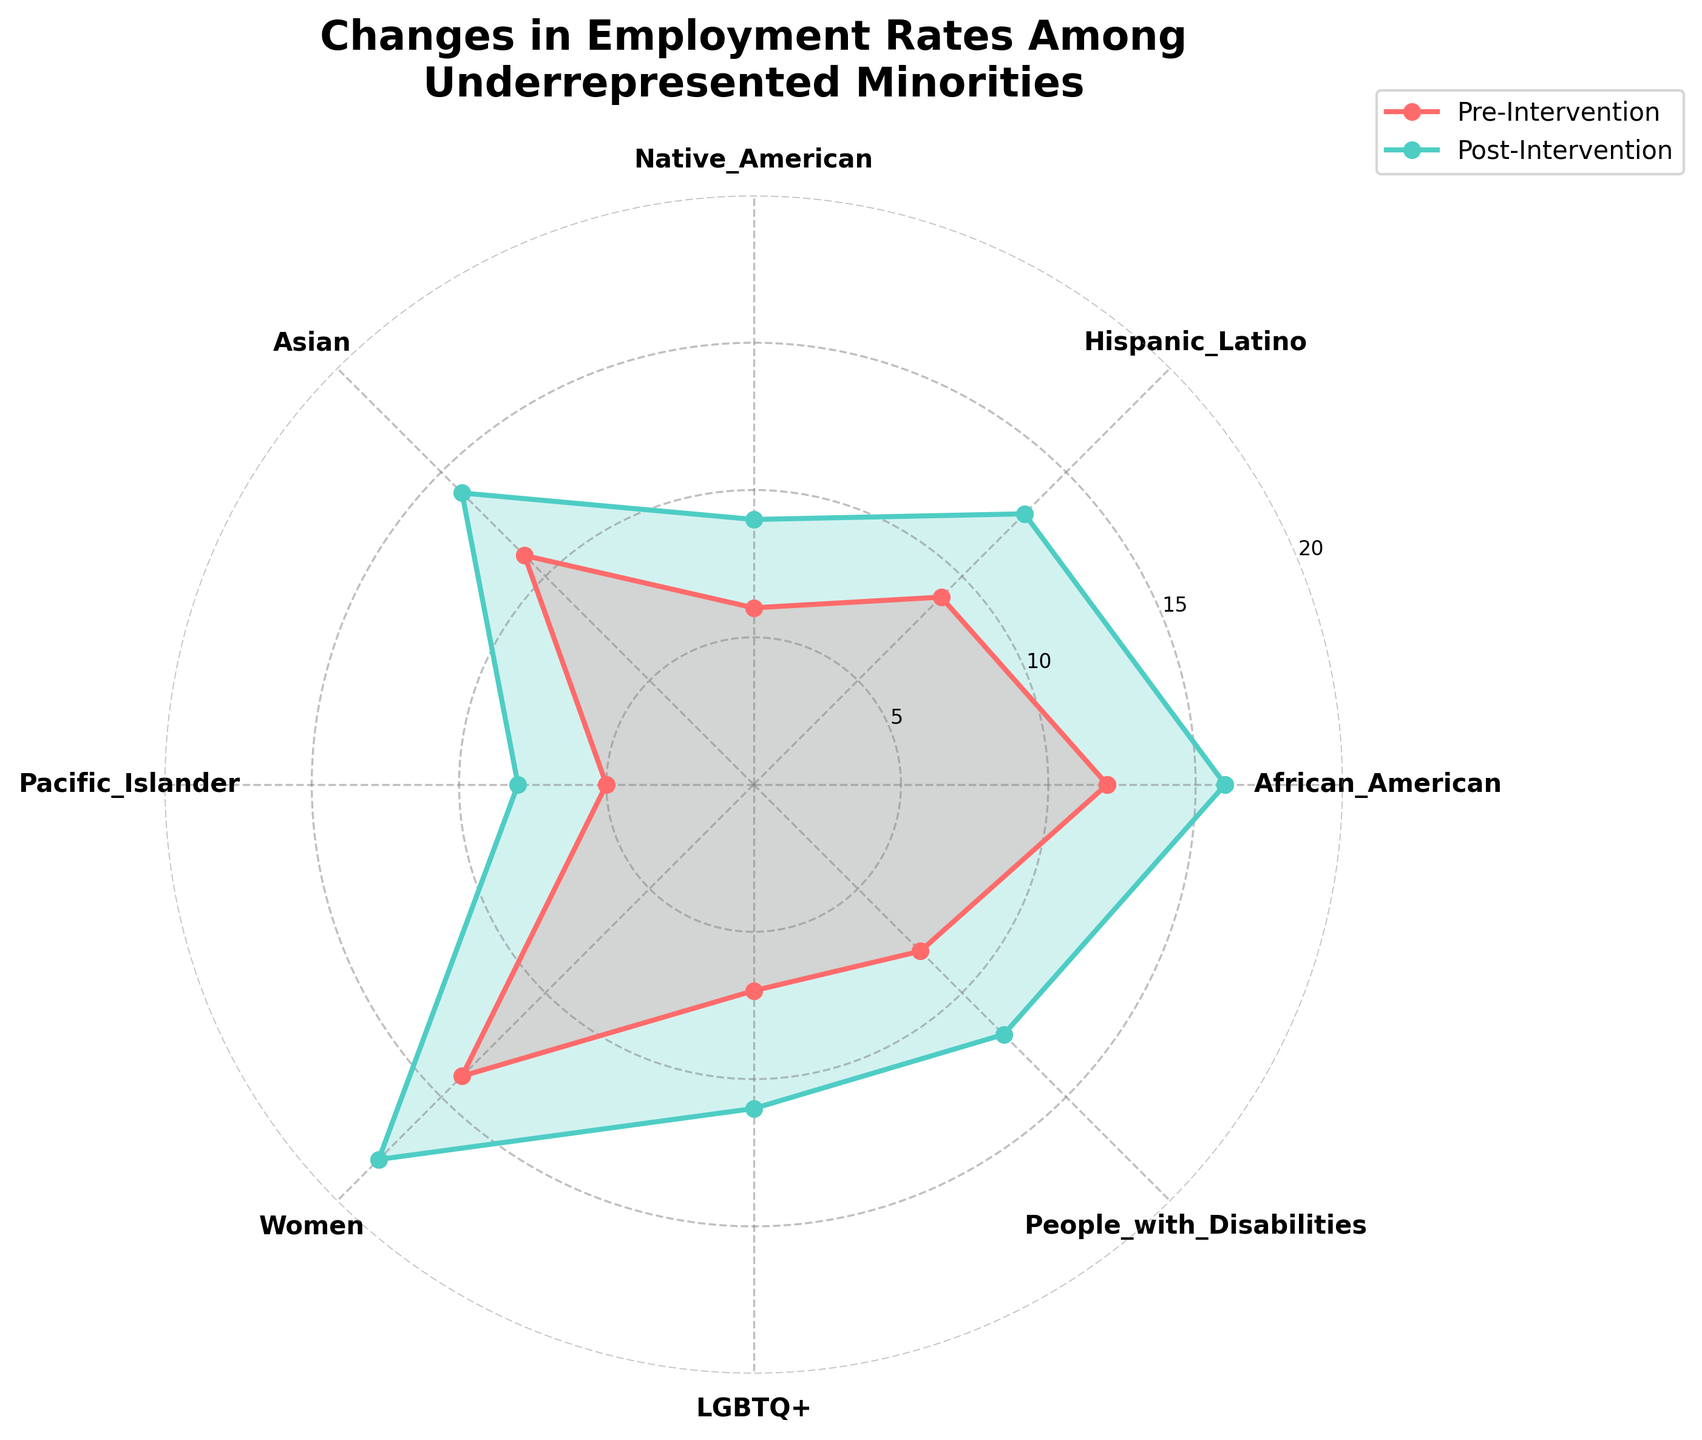What's the title of the figure? The title is usually the largest text on the plot, placed at the top center.
Answer: Changes in Employment Rates Among Underrepresented Minorities How does the employment rate for Women change from Pre-Intervention to Post-Intervention? Locate the Women category on the plot. Compare the difference in the radial lines for pre-intervention and post-intervention values.
Answer: It increases from 14 to 18 Which group had the highest increase in employment rates following the intervention? Calculate the difference in employment rates for each category by subtracting pre-intervention values from post-intervention values and compare them.
Answer: Women (increase of 4) What is the employment rate for LGBTQ+ populations before and after the intervention? Locate the LGBTQ+ category on the plot and read the values for the pre-intervention and post-intervention lines.
Answer: Before: 7, After: 11 What is the range of employment rates for African American individuals throughout the period? Identify the pre-intervention and post-intervention values for African American and find the difference between the highest and lowest values.
Answer: 12 to 16 Which group has the lowest employment rate post-intervention? Identify and compare the post-intervention values for all categories on the plot.
Answer: Pacific Islander with a rate of 8 What is the average pre-intervention employment rate across all groups? Sum up all pre-intervention rates and divide by the number of groups. (12+9+6+11+5+14+7+8)/8
Answer: 9 How does the Asian category’s change in employment rate compare to the Native American category? Calculate the difference for both categories: Asian (14 - 11) = 3, Native American (9 - 6) = 3. Analyze their changes.
Answer: Both increased by 3 Which group had the smallest increase in employment rate post-intervention? Find the smallest difference between pre and post-intervention values across all groups.
Answer: Pacific Islander with an increase of 3 What's the median post-intervention employment rate among all groups? Sort the post-intervention rates and find the median value. (8, 9, 11, 12, 13, 14, 16, 18) Median = (12+13)/2 = 12.5
Answer: 12.5 